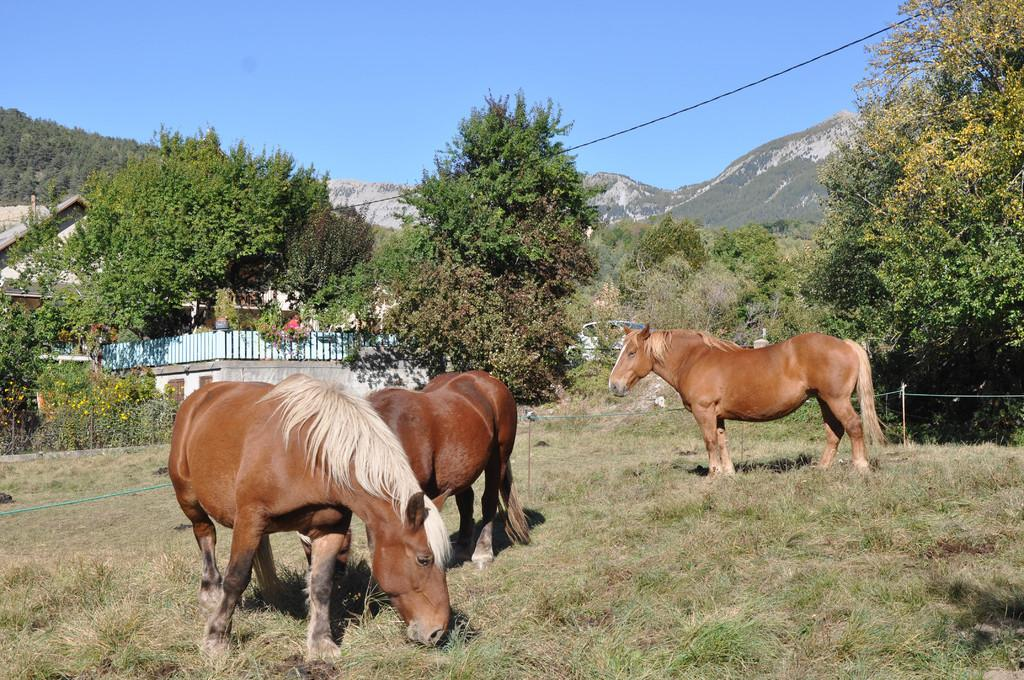How many horses are present in the image? There are three horses on the ground in the image. What can be seen in the image besides the horses? There is a rope, trees, mountains, a building, fences, sticks, and the sky visible in the image. What might be used to control or guide the horses in the image? The rope in the image might be used to control or guide the horses. What type of natural landscape is visible in the image? The image features mountains and trees, indicating a natural landscape. What type of structure is present in the image? There is a building in the image. What might be used to create boundaries or enclosures in the image? The fences in the image might be used to create boundaries or enclosures. What can be seen in the sky in the image? The sky is visible in the background of the image. What type of test is being conducted on the horses in the image? There is no indication in the image that a test is being conducted on the horses. 